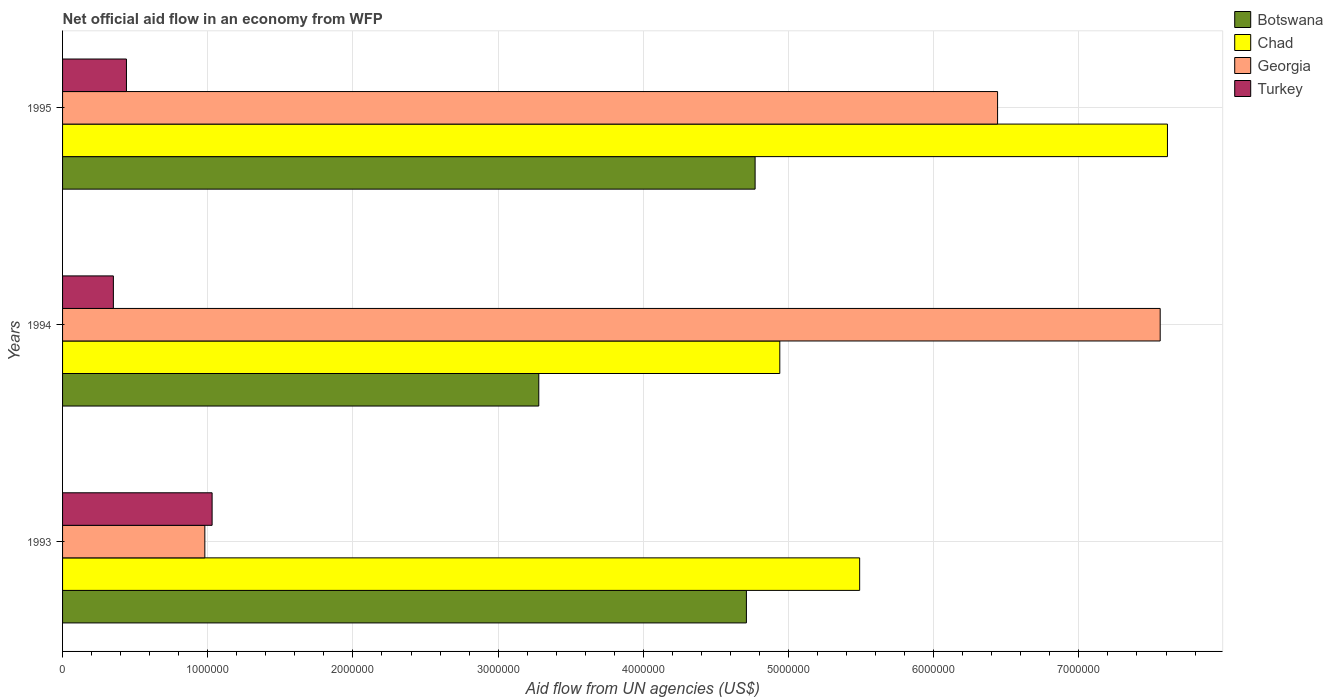How many groups of bars are there?
Keep it short and to the point. 3. Are the number of bars per tick equal to the number of legend labels?
Ensure brevity in your answer.  Yes. Are the number of bars on each tick of the Y-axis equal?
Ensure brevity in your answer.  Yes. In how many cases, is the number of bars for a given year not equal to the number of legend labels?
Offer a very short reply. 0. What is the net official aid flow in Chad in 1994?
Offer a very short reply. 4.94e+06. Across all years, what is the maximum net official aid flow in Georgia?
Your answer should be compact. 7.56e+06. Across all years, what is the minimum net official aid flow in Georgia?
Offer a very short reply. 9.80e+05. In which year was the net official aid flow in Turkey minimum?
Offer a very short reply. 1994. What is the total net official aid flow in Botswana in the graph?
Your answer should be very brief. 1.28e+07. What is the difference between the net official aid flow in Botswana in 1993 and that in 1994?
Ensure brevity in your answer.  1.43e+06. What is the difference between the net official aid flow in Turkey in 1993 and the net official aid flow in Chad in 1994?
Make the answer very short. -3.91e+06. What is the average net official aid flow in Botswana per year?
Make the answer very short. 4.25e+06. In the year 1994, what is the difference between the net official aid flow in Botswana and net official aid flow in Georgia?
Provide a short and direct response. -4.28e+06. What is the ratio of the net official aid flow in Turkey in 1993 to that in 1995?
Your answer should be very brief. 2.34. Is the net official aid flow in Georgia in 1993 less than that in 1994?
Make the answer very short. Yes. What is the difference between the highest and the second highest net official aid flow in Chad?
Give a very brief answer. 2.12e+06. What is the difference between the highest and the lowest net official aid flow in Georgia?
Give a very brief answer. 6.58e+06. In how many years, is the net official aid flow in Chad greater than the average net official aid flow in Chad taken over all years?
Make the answer very short. 1. Is the sum of the net official aid flow in Turkey in 1993 and 1994 greater than the maximum net official aid flow in Botswana across all years?
Your answer should be very brief. No. Is it the case that in every year, the sum of the net official aid flow in Georgia and net official aid flow in Botswana is greater than the sum of net official aid flow in Chad and net official aid flow in Turkey?
Offer a very short reply. No. What does the 3rd bar from the top in 1995 represents?
Your response must be concise. Chad. What does the 2nd bar from the bottom in 1994 represents?
Provide a short and direct response. Chad. How many bars are there?
Ensure brevity in your answer.  12. How are the legend labels stacked?
Your answer should be very brief. Vertical. What is the title of the graph?
Offer a terse response. Net official aid flow in an economy from WFP. Does "Moldova" appear as one of the legend labels in the graph?
Your answer should be very brief. No. What is the label or title of the X-axis?
Make the answer very short. Aid flow from UN agencies (US$). What is the label or title of the Y-axis?
Keep it short and to the point. Years. What is the Aid flow from UN agencies (US$) of Botswana in 1993?
Ensure brevity in your answer.  4.71e+06. What is the Aid flow from UN agencies (US$) in Chad in 1993?
Provide a short and direct response. 5.49e+06. What is the Aid flow from UN agencies (US$) in Georgia in 1993?
Make the answer very short. 9.80e+05. What is the Aid flow from UN agencies (US$) of Turkey in 1993?
Ensure brevity in your answer.  1.03e+06. What is the Aid flow from UN agencies (US$) of Botswana in 1994?
Provide a short and direct response. 3.28e+06. What is the Aid flow from UN agencies (US$) in Chad in 1994?
Your response must be concise. 4.94e+06. What is the Aid flow from UN agencies (US$) in Georgia in 1994?
Offer a very short reply. 7.56e+06. What is the Aid flow from UN agencies (US$) in Botswana in 1995?
Ensure brevity in your answer.  4.77e+06. What is the Aid flow from UN agencies (US$) in Chad in 1995?
Offer a very short reply. 7.61e+06. What is the Aid flow from UN agencies (US$) in Georgia in 1995?
Offer a terse response. 6.44e+06. What is the Aid flow from UN agencies (US$) of Turkey in 1995?
Keep it short and to the point. 4.40e+05. Across all years, what is the maximum Aid flow from UN agencies (US$) of Botswana?
Your response must be concise. 4.77e+06. Across all years, what is the maximum Aid flow from UN agencies (US$) of Chad?
Your response must be concise. 7.61e+06. Across all years, what is the maximum Aid flow from UN agencies (US$) of Georgia?
Provide a short and direct response. 7.56e+06. Across all years, what is the maximum Aid flow from UN agencies (US$) in Turkey?
Offer a very short reply. 1.03e+06. Across all years, what is the minimum Aid flow from UN agencies (US$) of Botswana?
Provide a short and direct response. 3.28e+06. Across all years, what is the minimum Aid flow from UN agencies (US$) of Chad?
Your answer should be very brief. 4.94e+06. Across all years, what is the minimum Aid flow from UN agencies (US$) of Georgia?
Give a very brief answer. 9.80e+05. What is the total Aid flow from UN agencies (US$) of Botswana in the graph?
Provide a short and direct response. 1.28e+07. What is the total Aid flow from UN agencies (US$) in Chad in the graph?
Your answer should be very brief. 1.80e+07. What is the total Aid flow from UN agencies (US$) in Georgia in the graph?
Your answer should be compact. 1.50e+07. What is the total Aid flow from UN agencies (US$) of Turkey in the graph?
Ensure brevity in your answer.  1.82e+06. What is the difference between the Aid flow from UN agencies (US$) in Botswana in 1993 and that in 1994?
Provide a short and direct response. 1.43e+06. What is the difference between the Aid flow from UN agencies (US$) of Chad in 1993 and that in 1994?
Make the answer very short. 5.50e+05. What is the difference between the Aid flow from UN agencies (US$) in Georgia in 1993 and that in 1994?
Ensure brevity in your answer.  -6.58e+06. What is the difference between the Aid flow from UN agencies (US$) of Turkey in 1993 and that in 1994?
Your response must be concise. 6.80e+05. What is the difference between the Aid flow from UN agencies (US$) of Chad in 1993 and that in 1995?
Give a very brief answer. -2.12e+06. What is the difference between the Aid flow from UN agencies (US$) of Georgia in 1993 and that in 1995?
Offer a very short reply. -5.46e+06. What is the difference between the Aid flow from UN agencies (US$) of Turkey in 1993 and that in 1995?
Offer a very short reply. 5.90e+05. What is the difference between the Aid flow from UN agencies (US$) of Botswana in 1994 and that in 1995?
Your response must be concise. -1.49e+06. What is the difference between the Aid flow from UN agencies (US$) in Chad in 1994 and that in 1995?
Offer a terse response. -2.67e+06. What is the difference between the Aid flow from UN agencies (US$) of Georgia in 1994 and that in 1995?
Your answer should be very brief. 1.12e+06. What is the difference between the Aid flow from UN agencies (US$) in Botswana in 1993 and the Aid flow from UN agencies (US$) in Chad in 1994?
Offer a very short reply. -2.30e+05. What is the difference between the Aid flow from UN agencies (US$) in Botswana in 1993 and the Aid flow from UN agencies (US$) in Georgia in 1994?
Offer a terse response. -2.85e+06. What is the difference between the Aid flow from UN agencies (US$) in Botswana in 1993 and the Aid flow from UN agencies (US$) in Turkey in 1994?
Offer a terse response. 4.36e+06. What is the difference between the Aid flow from UN agencies (US$) of Chad in 1993 and the Aid flow from UN agencies (US$) of Georgia in 1994?
Offer a very short reply. -2.07e+06. What is the difference between the Aid flow from UN agencies (US$) of Chad in 1993 and the Aid flow from UN agencies (US$) of Turkey in 1994?
Your answer should be compact. 5.14e+06. What is the difference between the Aid flow from UN agencies (US$) of Georgia in 1993 and the Aid flow from UN agencies (US$) of Turkey in 1994?
Your answer should be very brief. 6.30e+05. What is the difference between the Aid flow from UN agencies (US$) in Botswana in 1993 and the Aid flow from UN agencies (US$) in Chad in 1995?
Offer a terse response. -2.90e+06. What is the difference between the Aid flow from UN agencies (US$) in Botswana in 1993 and the Aid flow from UN agencies (US$) in Georgia in 1995?
Provide a short and direct response. -1.73e+06. What is the difference between the Aid flow from UN agencies (US$) in Botswana in 1993 and the Aid flow from UN agencies (US$) in Turkey in 1995?
Your response must be concise. 4.27e+06. What is the difference between the Aid flow from UN agencies (US$) of Chad in 1993 and the Aid flow from UN agencies (US$) of Georgia in 1995?
Ensure brevity in your answer.  -9.50e+05. What is the difference between the Aid flow from UN agencies (US$) of Chad in 1993 and the Aid flow from UN agencies (US$) of Turkey in 1995?
Offer a terse response. 5.05e+06. What is the difference between the Aid flow from UN agencies (US$) of Georgia in 1993 and the Aid flow from UN agencies (US$) of Turkey in 1995?
Your response must be concise. 5.40e+05. What is the difference between the Aid flow from UN agencies (US$) in Botswana in 1994 and the Aid flow from UN agencies (US$) in Chad in 1995?
Provide a succinct answer. -4.33e+06. What is the difference between the Aid flow from UN agencies (US$) in Botswana in 1994 and the Aid flow from UN agencies (US$) in Georgia in 1995?
Give a very brief answer. -3.16e+06. What is the difference between the Aid flow from UN agencies (US$) of Botswana in 1994 and the Aid flow from UN agencies (US$) of Turkey in 1995?
Keep it short and to the point. 2.84e+06. What is the difference between the Aid flow from UN agencies (US$) in Chad in 1994 and the Aid flow from UN agencies (US$) in Georgia in 1995?
Provide a short and direct response. -1.50e+06. What is the difference between the Aid flow from UN agencies (US$) in Chad in 1994 and the Aid flow from UN agencies (US$) in Turkey in 1995?
Ensure brevity in your answer.  4.50e+06. What is the difference between the Aid flow from UN agencies (US$) of Georgia in 1994 and the Aid flow from UN agencies (US$) of Turkey in 1995?
Keep it short and to the point. 7.12e+06. What is the average Aid flow from UN agencies (US$) of Botswana per year?
Make the answer very short. 4.25e+06. What is the average Aid flow from UN agencies (US$) of Chad per year?
Keep it short and to the point. 6.01e+06. What is the average Aid flow from UN agencies (US$) in Georgia per year?
Make the answer very short. 4.99e+06. What is the average Aid flow from UN agencies (US$) of Turkey per year?
Give a very brief answer. 6.07e+05. In the year 1993, what is the difference between the Aid flow from UN agencies (US$) in Botswana and Aid flow from UN agencies (US$) in Chad?
Offer a very short reply. -7.80e+05. In the year 1993, what is the difference between the Aid flow from UN agencies (US$) of Botswana and Aid flow from UN agencies (US$) of Georgia?
Keep it short and to the point. 3.73e+06. In the year 1993, what is the difference between the Aid flow from UN agencies (US$) of Botswana and Aid flow from UN agencies (US$) of Turkey?
Provide a short and direct response. 3.68e+06. In the year 1993, what is the difference between the Aid flow from UN agencies (US$) of Chad and Aid flow from UN agencies (US$) of Georgia?
Ensure brevity in your answer.  4.51e+06. In the year 1993, what is the difference between the Aid flow from UN agencies (US$) of Chad and Aid flow from UN agencies (US$) of Turkey?
Give a very brief answer. 4.46e+06. In the year 1994, what is the difference between the Aid flow from UN agencies (US$) of Botswana and Aid flow from UN agencies (US$) of Chad?
Provide a succinct answer. -1.66e+06. In the year 1994, what is the difference between the Aid flow from UN agencies (US$) of Botswana and Aid flow from UN agencies (US$) of Georgia?
Provide a short and direct response. -4.28e+06. In the year 1994, what is the difference between the Aid flow from UN agencies (US$) in Botswana and Aid flow from UN agencies (US$) in Turkey?
Your answer should be very brief. 2.93e+06. In the year 1994, what is the difference between the Aid flow from UN agencies (US$) in Chad and Aid flow from UN agencies (US$) in Georgia?
Your answer should be compact. -2.62e+06. In the year 1994, what is the difference between the Aid flow from UN agencies (US$) of Chad and Aid flow from UN agencies (US$) of Turkey?
Your answer should be very brief. 4.59e+06. In the year 1994, what is the difference between the Aid flow from UN agencies (US$) of Georgia and Aid flow from UN agencies (US$) of Turkey?
Provide a succinct answer. 7.21e+06. In the year 1995, what is the difference between the Aid flow from UN agencies (US$) in Botswana and Aid flow from UN agencies (US$) in Chad?
Offer a very short reply. -2.84e+06. In the year 1995, what is the difference between the Aid flow from UN agencies (US$) of Botswana and Aid flow from UN agencies (US$) of Georgia?
Your answer should be very brief. -1.67e+06. In the year 1995, what is the difference between the Aid flow from UN agencies (US$) in Botswana and Aid flow from UN agencies (US$) in Turkey?
Your answer should be very brief. 4.33e+06. In the year 1995, what is the difference between the Aid flow from UN agencies (US$) of Chad and Aid flow from UN agencies (US$) of Georgia?
Your answer should be compact. 1.17e+06. In the year 1995, what is the difference between the Aid flow from UN agencies (US$) in Chad and Aid flow from UN agencies (US$) in Turkey?
Offer a terse response. 7.17e+06. What is the ratio of the Aid flow from UN agencies (US$) of Botswana in 1993 to that in 1994?
Keep it short and to the point. 1.44. What is the ratio of the Aid flow from UN agencies (US$) of Chad in 1993 to that in 1994?
Provide a succinct answer. 1.11. What is the ratio of the Aid flow from UN agencies (US$) of Georgia in 1993 to that in 1994?
Offer a terse response. 0.13. What is the ratio of the Aid flow from UN agencies (US$) in Turkey in 1993 to that in 1994?
Offer a terse response. 2.94. What is the ratio of the Aid flow from UN agencies (US$) of Botswana in 1993 to that in 1995?
Make the answer very short. 0.99. What is the ratio of the Aid flow from UN agencies (US$) in Chad in 1993 to that in 1995?
Your response must be concise. 0.72. What is the ratio of the Aid flow from UN agencies (US$) of Georgia in 1993 to that in 1995?
Ensure brevity in your answer.  0.15. What is the ratio of the Aid flow from UN agencies (US$) of Turkey in 1993 to that in 1995?
Offer a very short reply. 2.34. What is the ratio of the Aid flow from UN agencies (US$) of Botswana in 1994 to that in 1995?
Your answer should be compact. 0.69. What is the ratio of the Aid flow from UN agencies (US$) in Chad in 1994 to that in 1995?
Make the answer very short. 0.65. What is the ratio of the Aid flow from UN agencies (US$) in Georgia in 1994 to that in 1995?
Offer a terse response. 1.17. What is the ratio of the Aid flow from UN agencies (US$) of Turkey in 1994 to that in 1995?
Provide a short and direct response. 0.8. What is the difference between the highest and the second highest Aid flow from UN agencies (US$) in Botswana?
Your response must be concise. 6.00e+04. What is the difference between the highest and the second highest Aid flow from UN agencies (US$) in Chad?
Keep it short and to the point. 2.12e+06. What is the difference between the highest and the second highest Aid flow from UN agencies (US$) of Georgia?
Your answer should be compact. 1.12e+06. What is the difference between the highest and the second highest Aid flow from UN agencies (US$) in Turkey?
Your answer should be very brief. 5.90e+05. What is the difference between the highest and the lowest Aid flow from UN agencies (US$) in Botswana?
Make the answer very short. 1.49e+06. What is the difference between the highest and the lowest Aid flow from UN agencies (US$) in Chad?
Provide a succinct answer. 2.67e+06. What is the difference between the highest and the lowest Aid flow from UN agencies (US$) in Georgia?
Your answer should be very brief. 6.58e+06. What is the difference between the highest and the lowest Aid flow from UN agencies (US$) of Turkey?
Your answer should be very brief. 6.80e+05. 